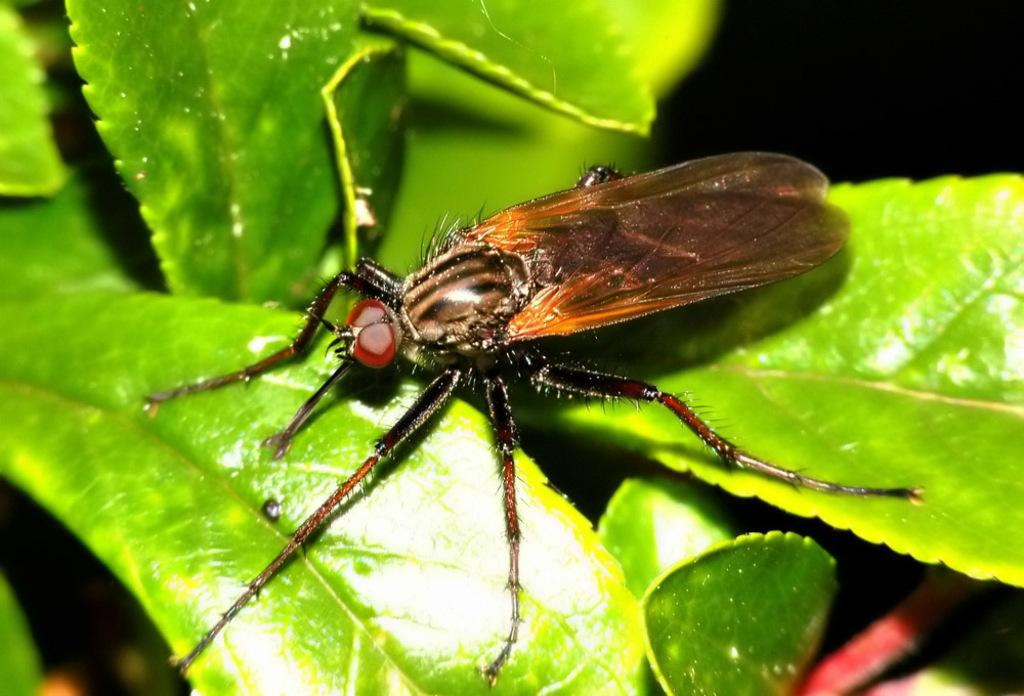What is the main subject of the picture? The main subject of the picture is an insect. Where is the insect located in the image? The insect is on the leaves in the image. What can be observed about the background of the image? The background of the image is dark. What type of ray can be seen swimming in the background of the image? There is no ray present in the image; it features an insect on leaves with a dark background. How does the insect's presence in the image make you feel? The image does not convey any emotions or feelings, so it cannot be determined how the insect's presence might make someone feel. 